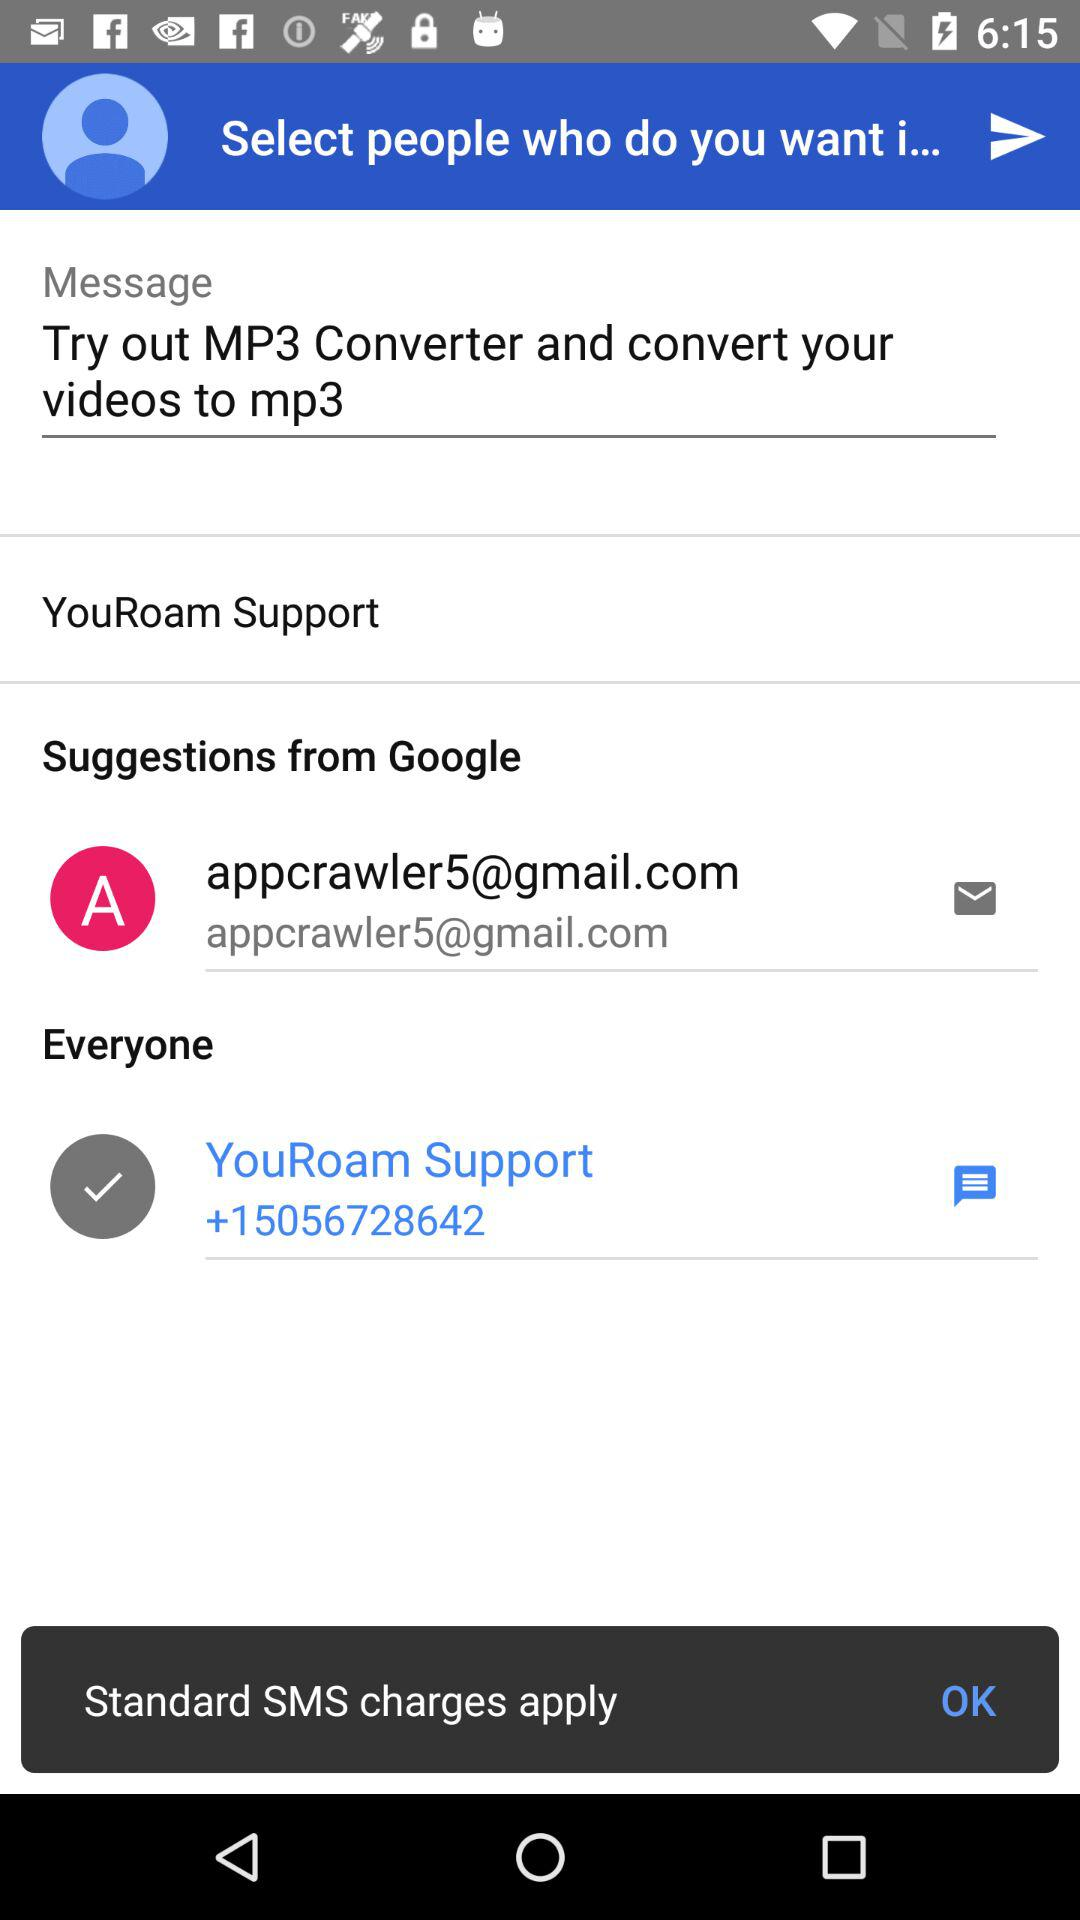What is the contact number of the "YouRoam" support? The contact number is +15056728642. 